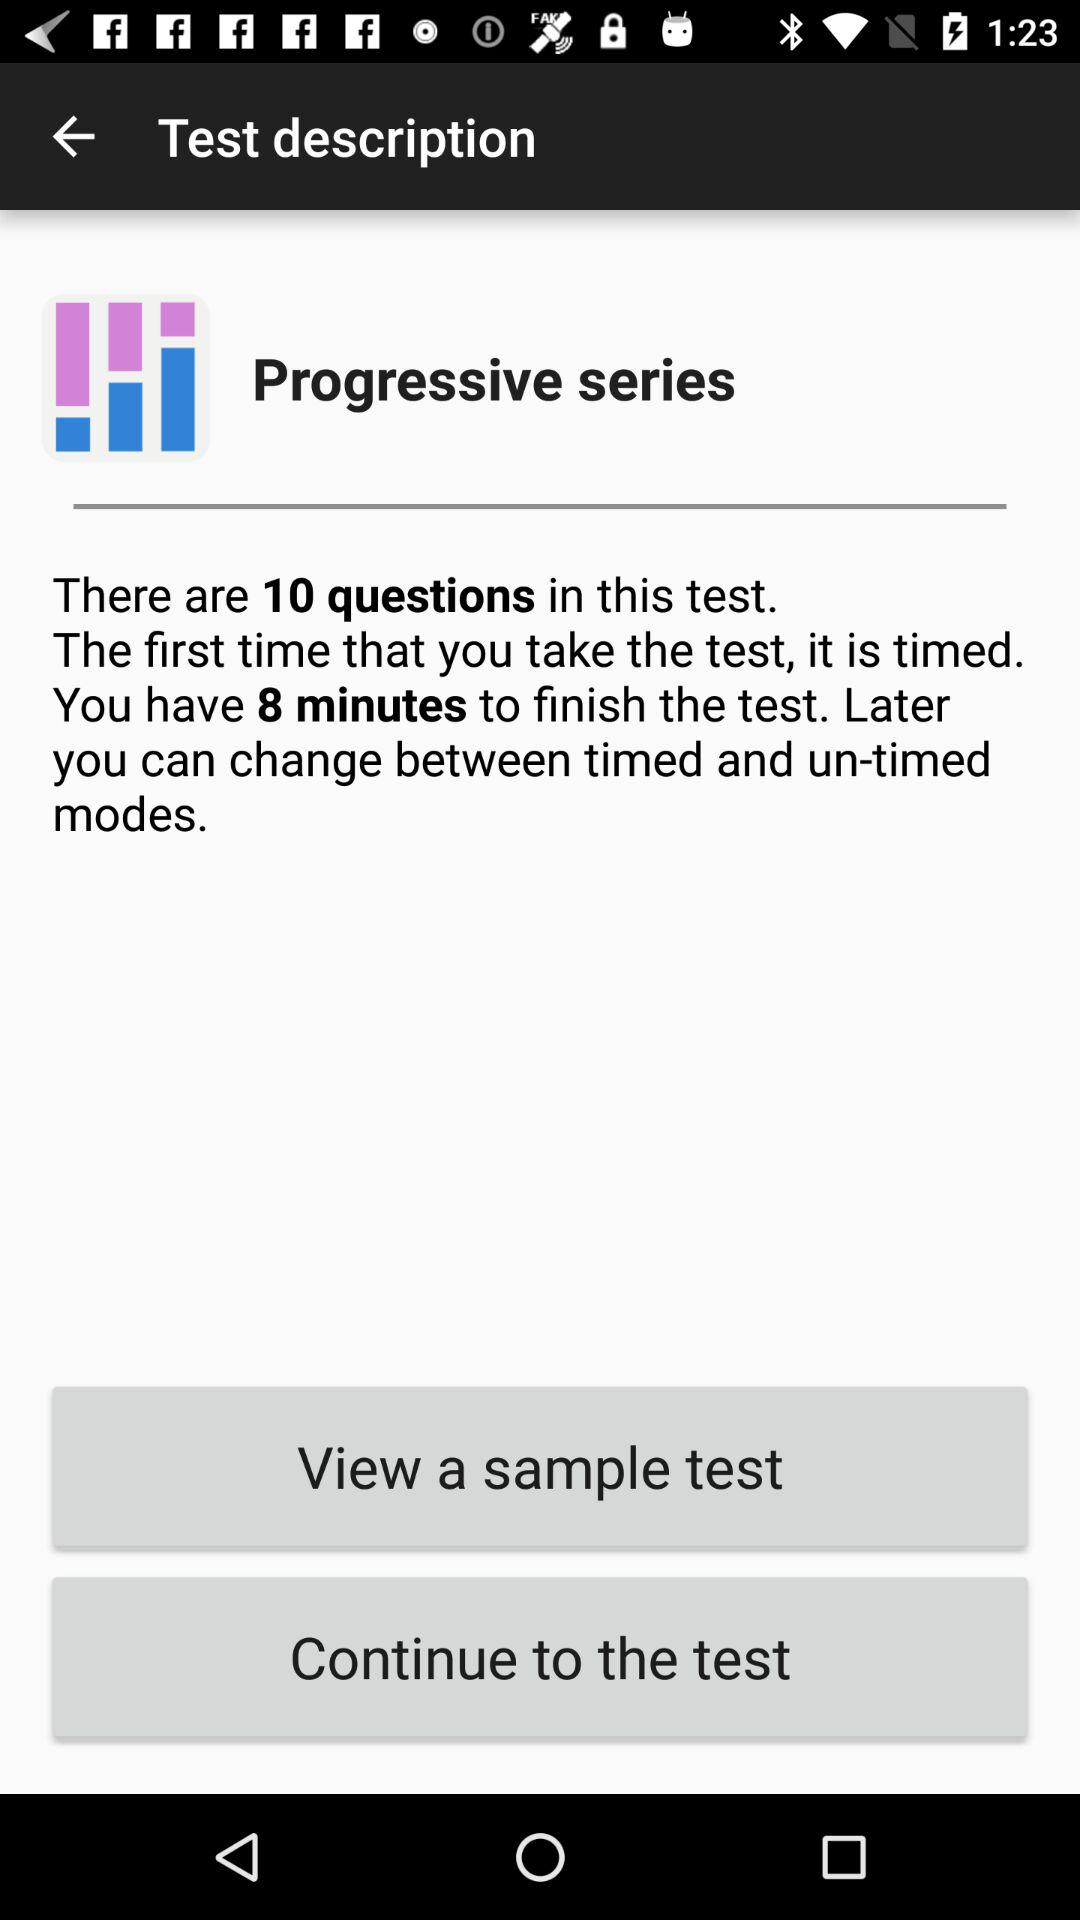How many minutes are given to finish the test? There are 8 minutes given to finish the test. 